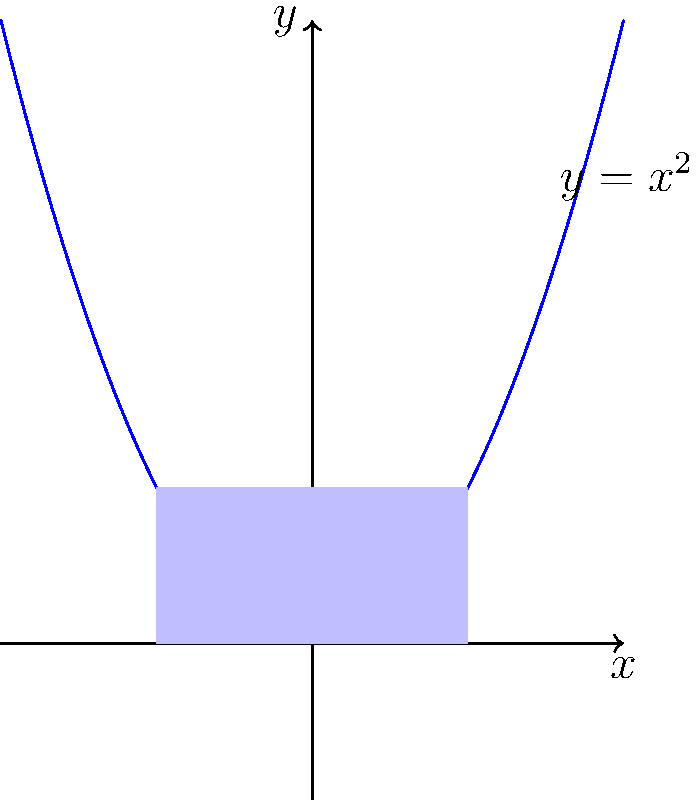Calculate the area under the parabola $y = x^2$ from $x = -1$ to $x = 1$ using integration. Then, write a simple VBA function to approximate this area using the trapezoidal rule with 100 subintervals. To solve this problem, we'll follow these steps:

1. Calculate the exact area using integration:
   $$A = \int_{-1}^{1} x^2 dx = \left[\frac{x^3}{3}\right]_{-1}^{1} = \frac{1^3}{3} - \frac{(-1)^3}{3} = \frac{1}{3} - \left(-\frac{1}{3}\right) = \frac{2}{3}$$

2. To approximate the area using the trapezoidal rule with 100 subintervals, we can use the following formula:
   $$A \approx \frac{b-a}{2n}\left[f(a) + 2\sum_{i=1}^{n-1}f(x_i) + f(b)\right]$$
   where $a=-1$, $b=1$, $n=100$, and $f(x)=x^2$

3. We can implement this in VBA as follows:

```vba
Function TrapezoidalArea() As Double
    Dim a As Double, b As Double, n As Integer
    Dim h As Double, sum As Double, x As Double
    
    a = -1
    b = 1
    n = 100
    
    h = (b - a) / n
    sum = a ^ 2 + b ^ 2
    
    For i = 1 To n - 1
        x = a + i * h
        sum = sum + 2 * x ^ 2
    Next i
    
    TrapezoidalArea = h / 2 * sum
End Function
```

4. This function will return an approximation of the area, which should be close to the exact value of $\frac{2}{3}$.
Answer: Exact area: $\frac{2}{3}$. VBA function for trapezoidal approximation provided. 